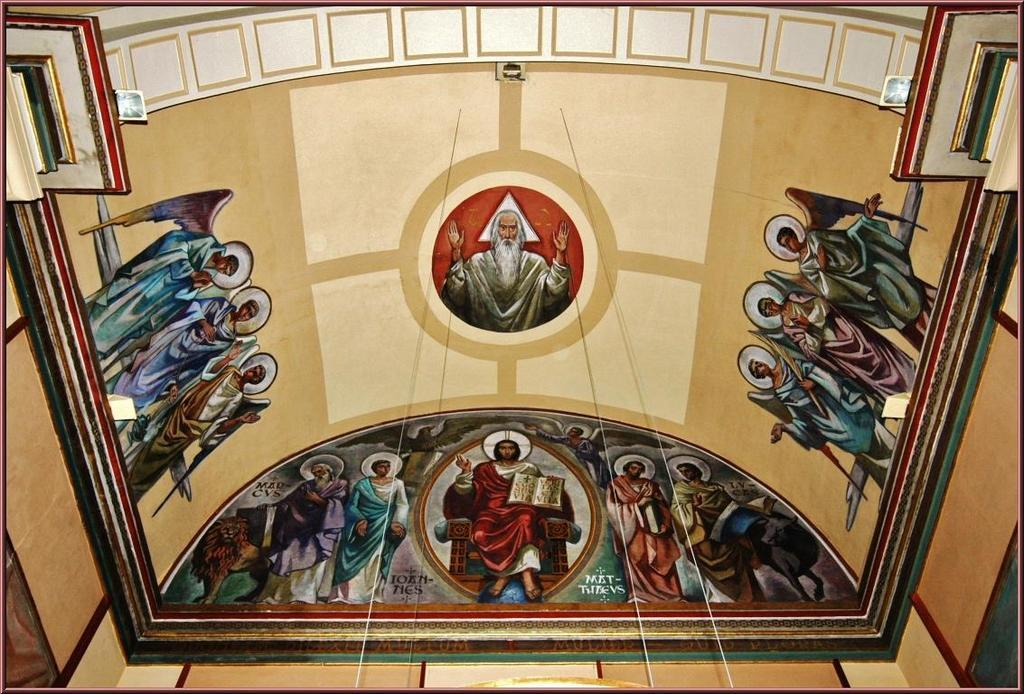What part of a room or building is shown in the image? The image appears to depict a ceiling. What can be seen on the ceiling in the image? There is a painting of persons on the ceiling. What is visible on the left side of the image? There is a wall on the left side of the image. What type of hospital equipment can be seen in the image? There is no hospital equipment present in the image; it depicts a ceiling with a painting of persons. How many legs are visible in the image? There are no legs visible in the image, as it depicts a ceiling with a painting of persons. 